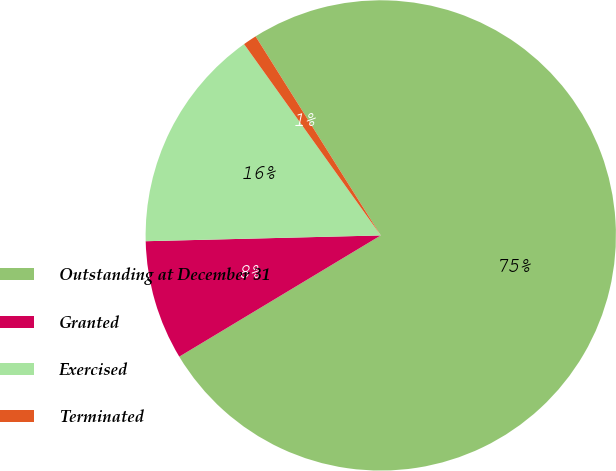Convert chart. <chart><loc_0><loc_0><loc_500><loc_500><pie_chart><fcel>Outstanding at December 31<fcel>Granted<fcel>Exercised<fcel>Terminated<nl><fcel>75.32%<fcel>8.23%<fcel>15.52%<fcel>0.94%<nl></chart> 